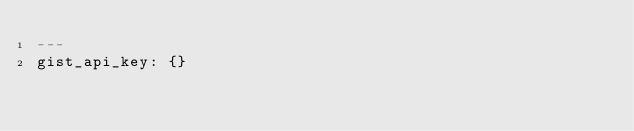Convert code to text. <code><loc_0><loc_0><loc_500><loc_500><_YAML_>---
gist_api_key: {}</code> 